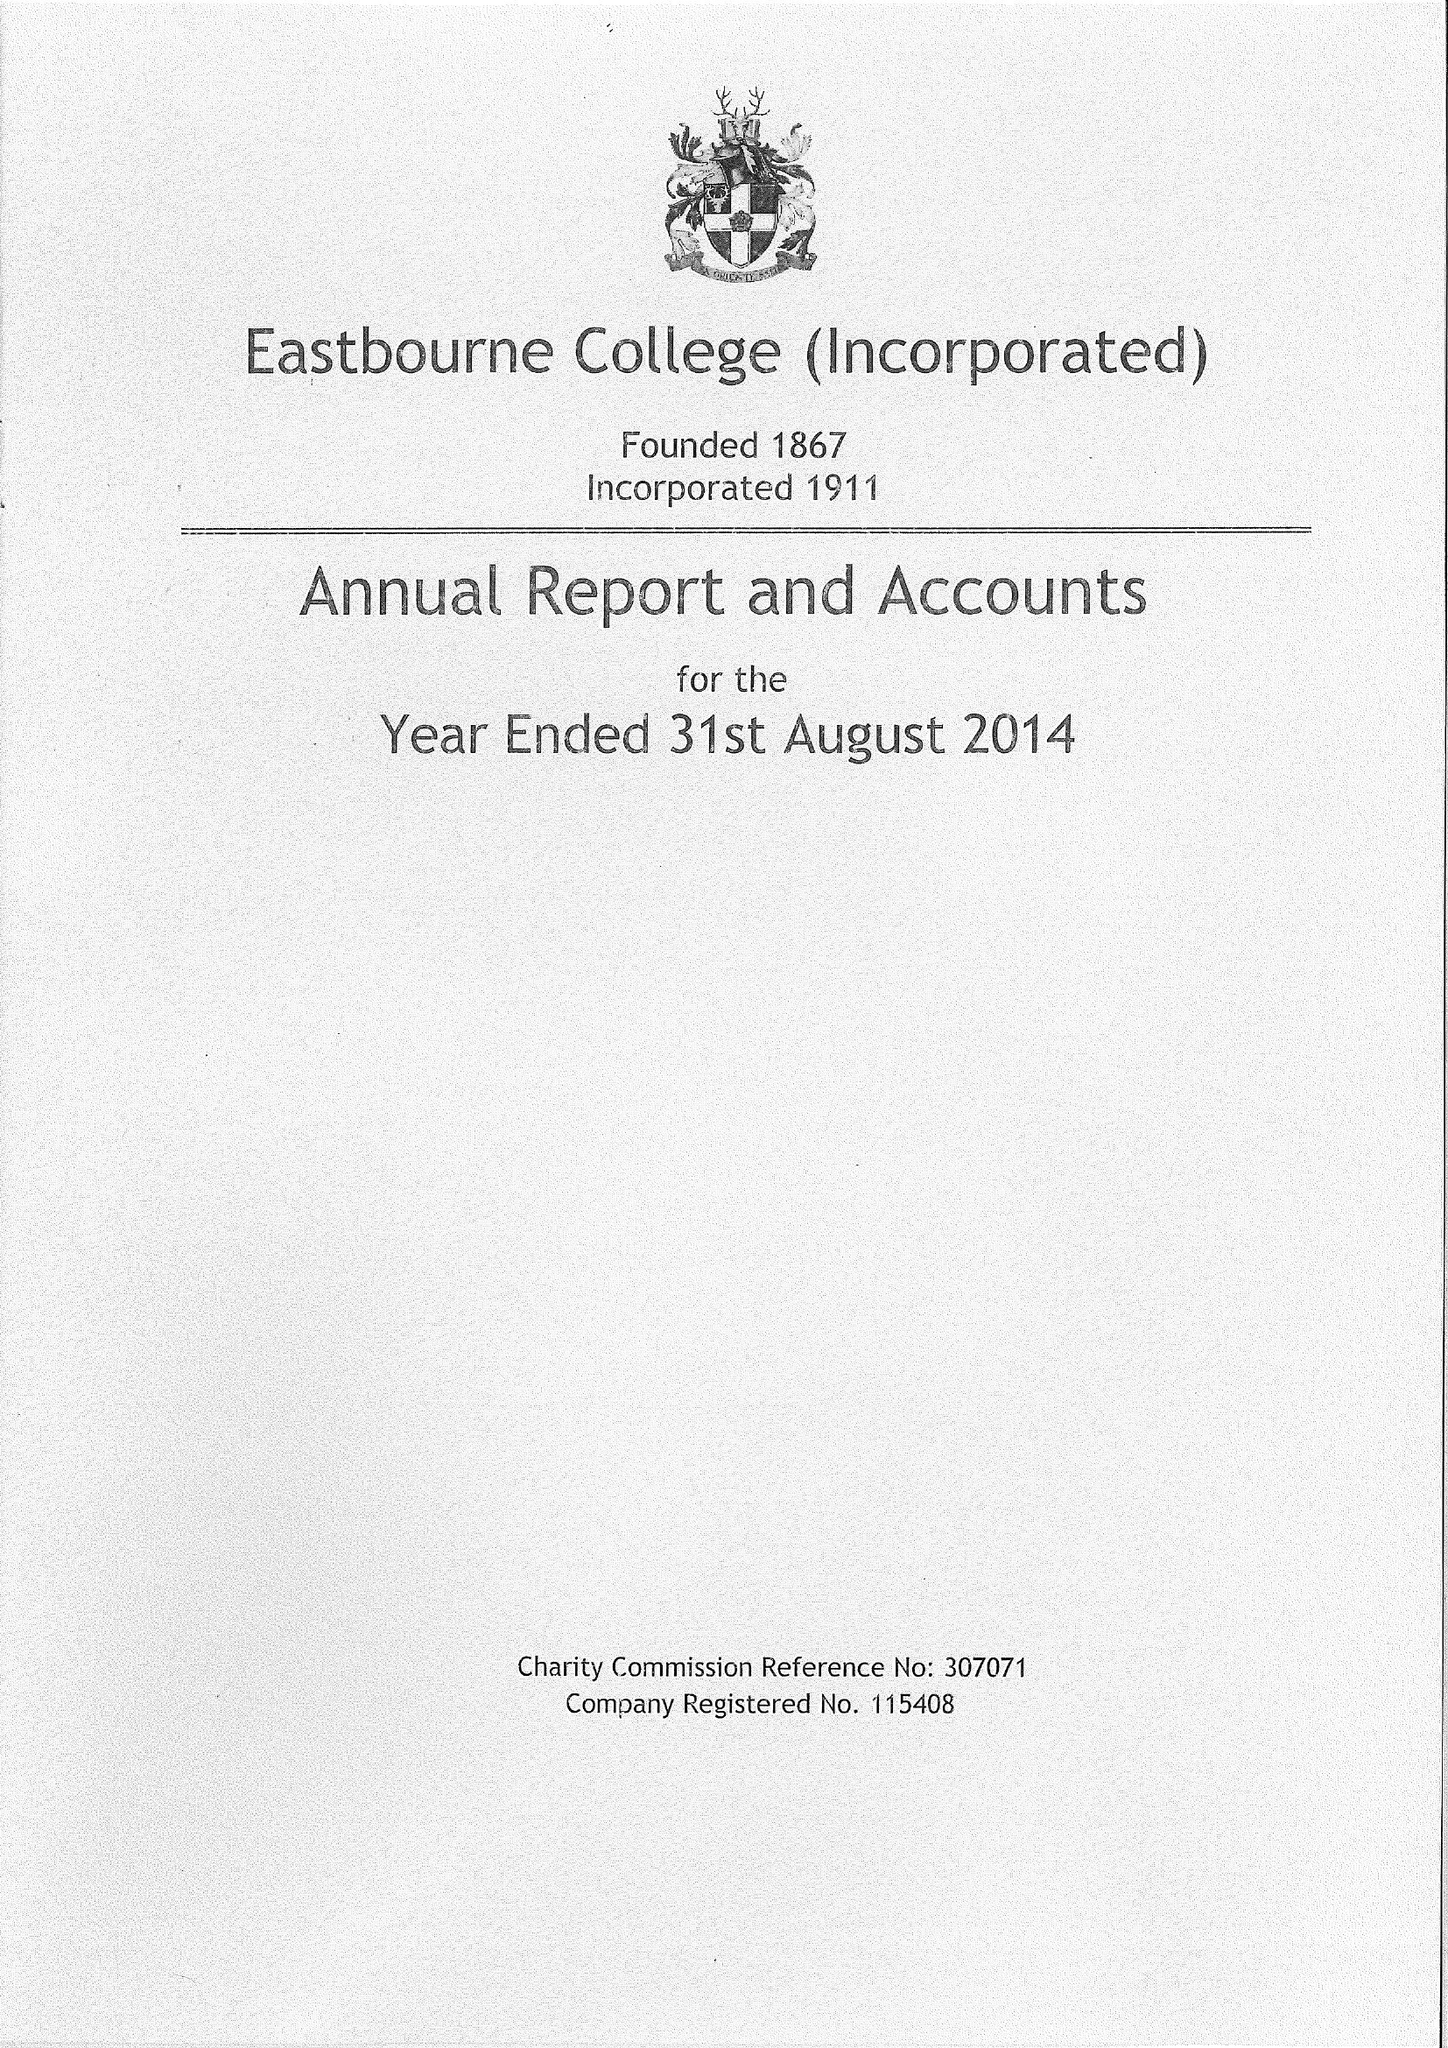What is the value for the spending_annually_in_british_pounds?
Answer the question using a single word or phrase. 19038000.00 